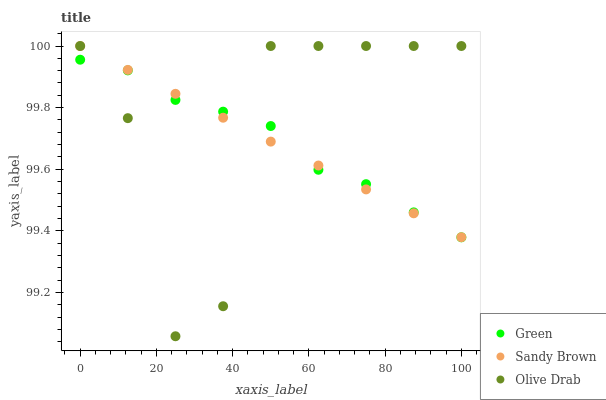Does Sandy Brown have the minimum area under the curve?
Answer yes or no. Yes. Does Olive Drab have the maximum area under the curve?
Answer yes or no. Yes. Does Green have the minimum area under the curve?
Answer yes or no. No. Does Green have the maximum area under the curve?
Answer yes or no. No. Is Sandy Brown the smoothest?
Answer yes or no. Yes. Is Olive Drab the roughest?
Answer yes or no. Yes. Is Green the smoothest?
Answer yes or no. No. Is Green the roughest?
Answer yes or no. No. Does Olive Drab have the lowest value?
Answer yes or no. Yes. Does Green have the lowest value?
Answer yes or no. No. Does Olive Drab have the highest value?
Answer yes or no. Yes. Does Green have the highest value?
Answer yes or no. No. Does Green intersect Sandy Brown?
Answer yes or no. Yes. Is Green less than Sandy Brown?
Answer yes or no. No. Is Green greater than Sandy Brown?
Answer yes or no. No. 